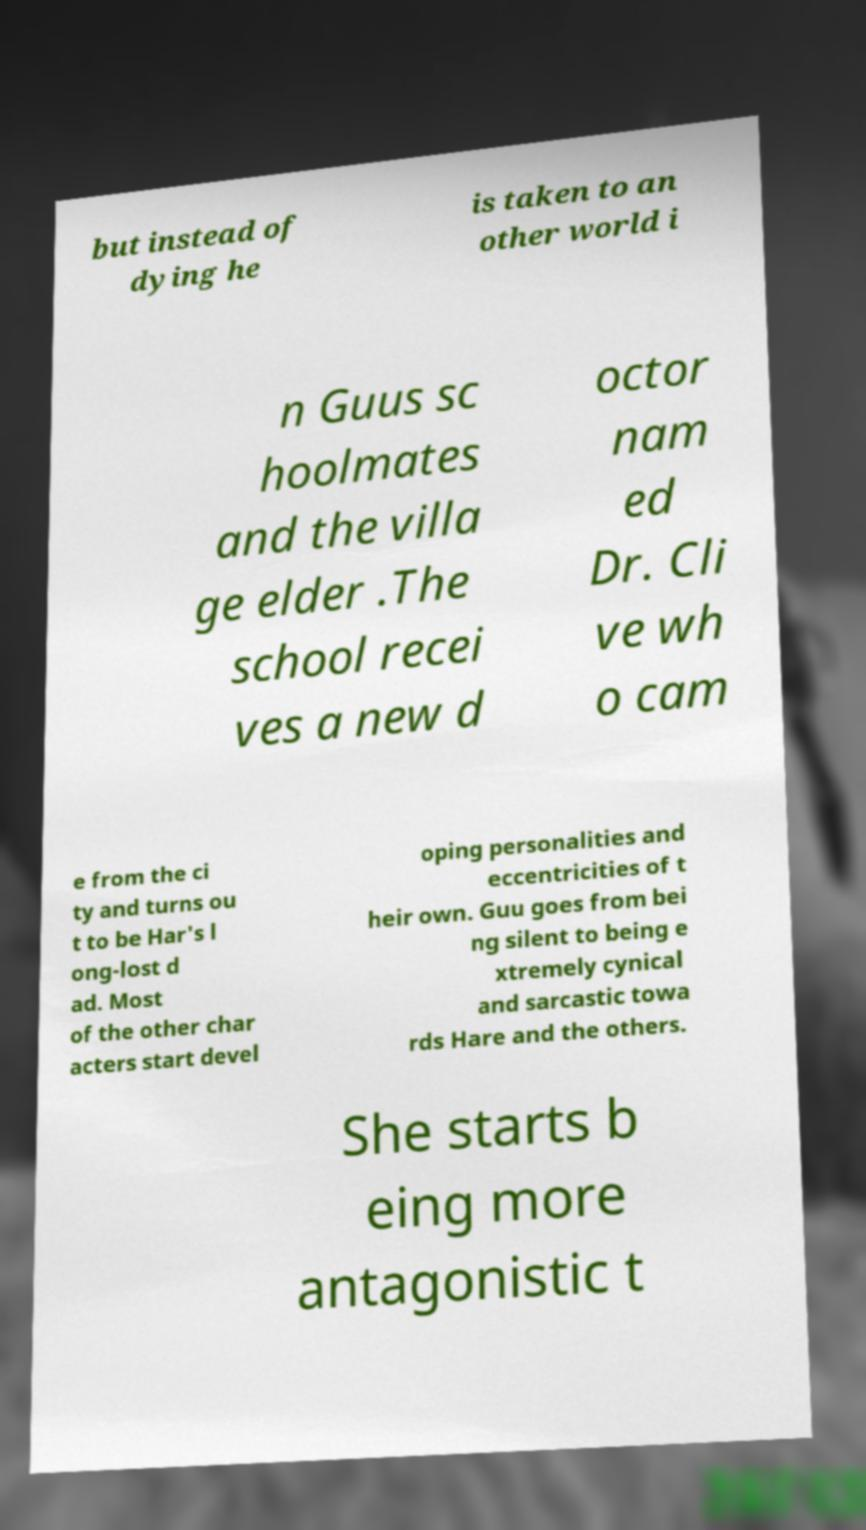Please identify and transcribe the text found in this image. but instead of dying he is taken to an other world i n Guus sc hoolmates and the villa ge elder .The school recei ves a new d octor nam ed Dr. Cli ve wh o cam e from the ci ty and turns ou t to be Har's l ong-lost d ad. Most of the other char acters start devel oping personalities and eccentricities of t heir own. Guu goes from bei ng silent to being e xtremely cynical and sarcastic towa rds Hare and the others. She starts b eing more antagonistic t 